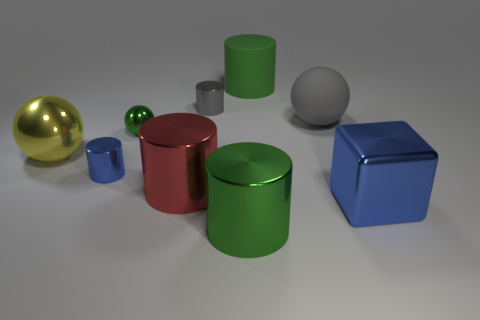Subtract all green metal balls. How many balls are left? 2 Subtract all cubes. How many objects are left? 8 Add 1 small purple rubber spheres. How many objects exist? 10 Subtract all gray cylinders. How many cylinders are left? 4 Subtract 1 blue cylinders. How many objects are left? 8 Subtract 1 spheres. How many spheres are left? 2 Subtract all green blocks. Subtract all cyan cylinders. How many blocks are left? 1 Subtract all green cubes. How many red cylinders are left? 1 Subtract all large gray things. Subtract all yellow cylinders. How many objects are left? 8 Add 2 small green balls. How many small green balls are left? 3 